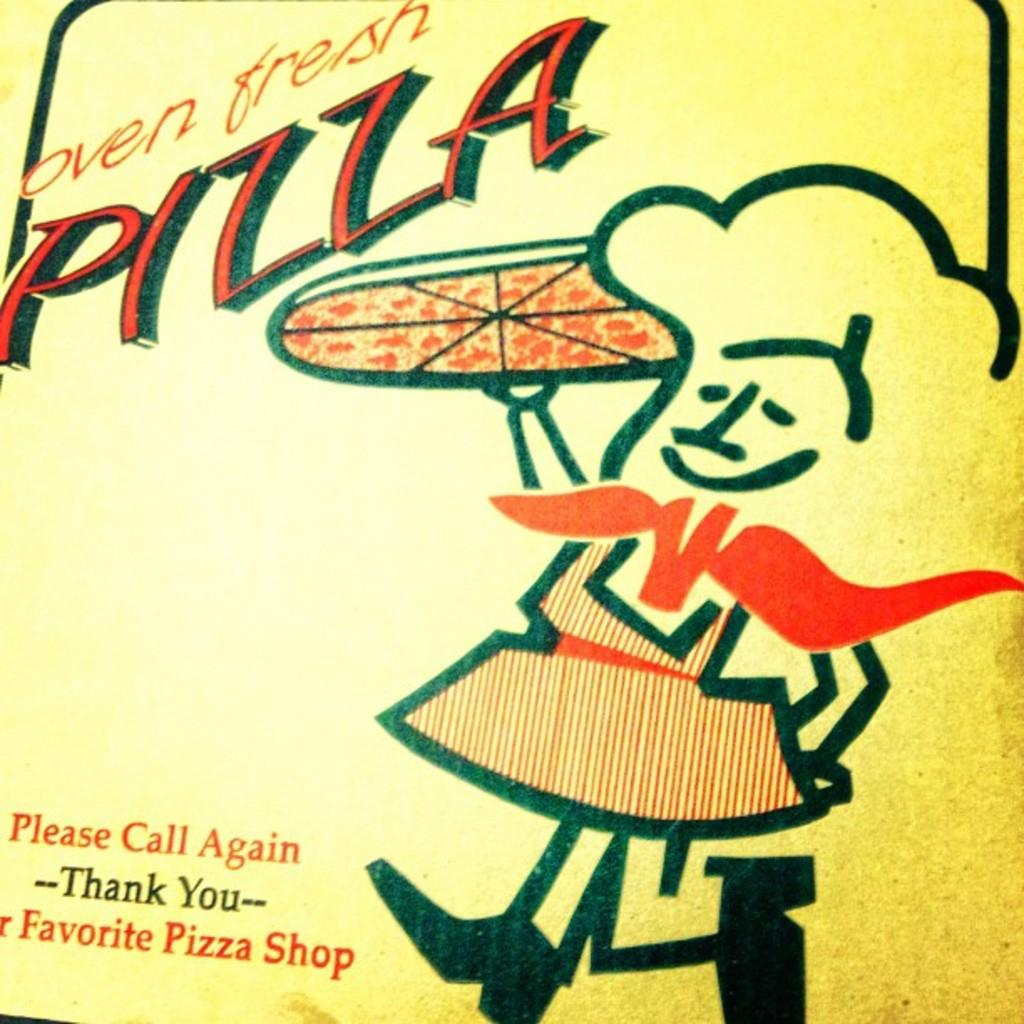Provide a one-sentence caption for the provided image. The box from a pizza shop describes its pizza as being oven fresh. 